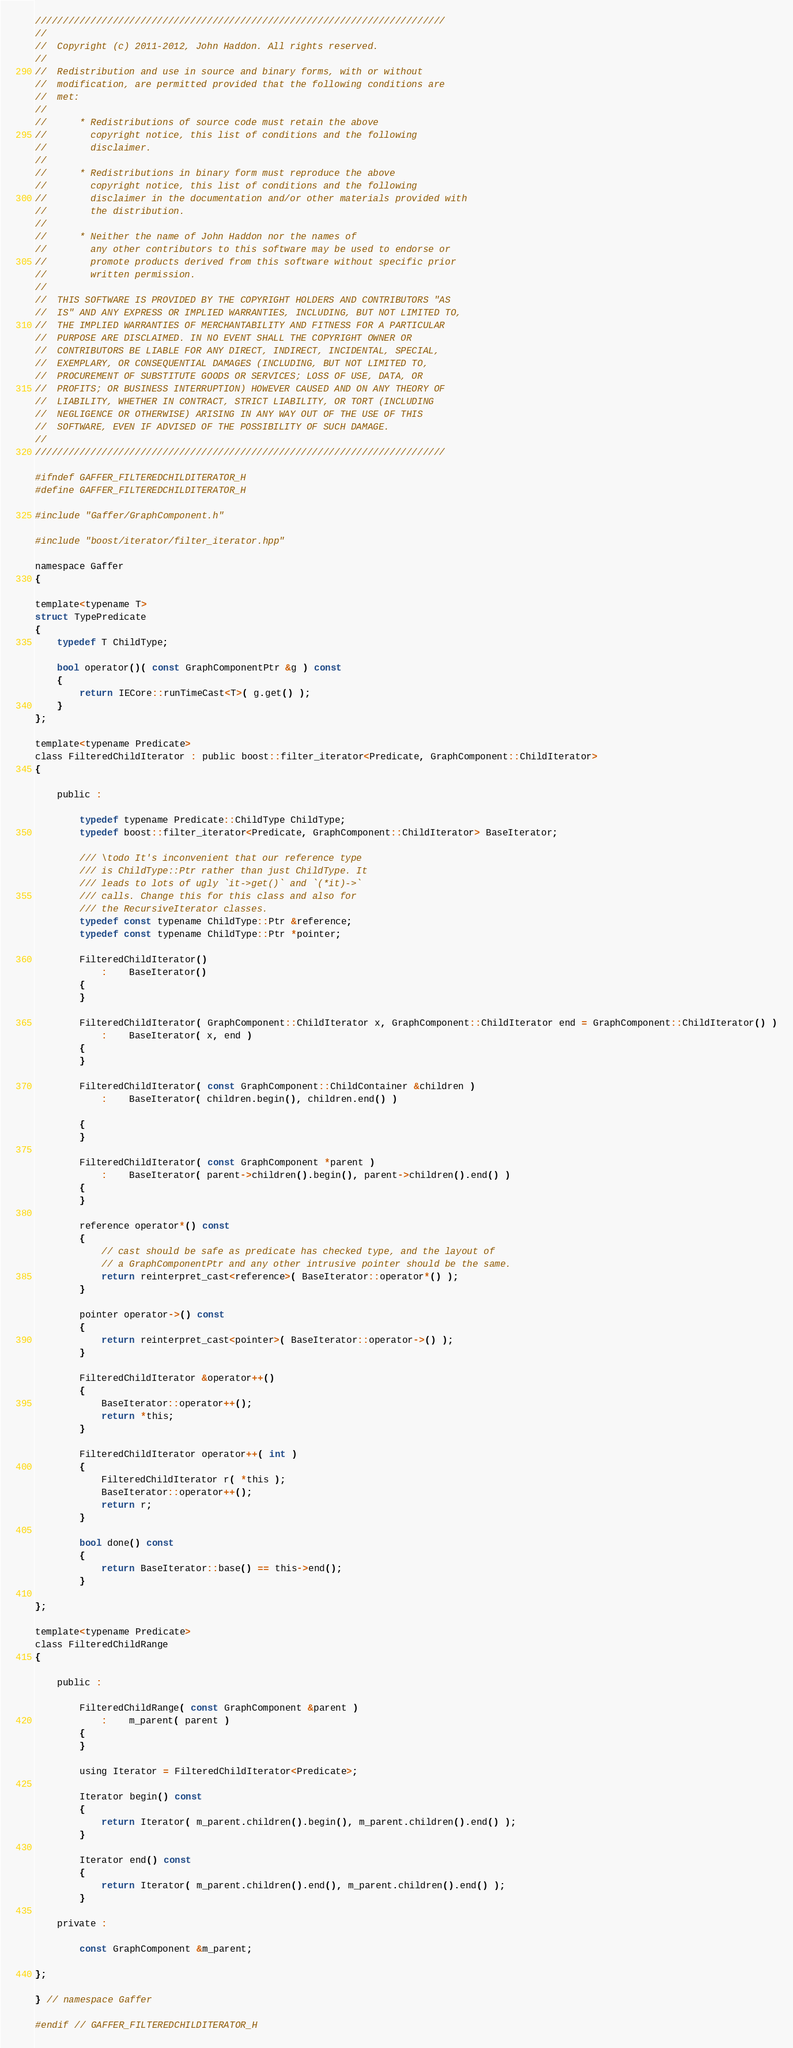<code> <loc_0><loc_0><loc_500><loc_500><_C_>//////////////////////////////////////////////////////////////////////////
//
//  Copyright (c) 2011-2012, John Haddon. All rights reserved.
//
//  Redistribution and use in source and binary forms, with or without
//  modification, are permitted provided that the following conditions are
//  met:
//
//      * Redistributions of source code must retain the above
//        copyright notice, this list of conditions and the following
//        disclaimer.
//
//      * Redistributions in binary form must reproduce the above
//        copyright notice, this list of conditions and the following
//        disclaimer in the documentation and/or other materials provided with
//        the distribution.
//
//      * Neither the name of John Haddon nor the names of
//        any other contributors to this software may be used to endorse or
//        promote products derived from this software without specific prior
//        written permission.
//
//  THIS SOFTWARE IS PROVIDED BY THE COPYRIGHT HOLDERS AND CONTRIBUTORS "AS
//  IS" AND ANY EXPRESS OR IMPLIED WARRANTIES, INCLUDING, BUT NOT LIMITED TO,
//  THE IMPLIED WARRANTIES OF MERCHANTABILITY AND FITNESS FOR A PARTICULAR
//  PURPOSE ARE DISCLAIMED. IN NO EVENT SHALL THE COPYRIGHT OWNER OR
//  CONTRIBUTORS BE LIABLE FOR ANY DIRECT, INDIRECT, INCIDENTAL, SPECIAL,
//  EXEMPLARY, OR CONSEQUENTIAL DAMAGES (INCLUDING, BUT NOT LIMITED TO,
//  PROCUREMENT OF SUBSTITUTE GOODS OR SERVICES; LOSS OF USE, DATA, OR
//  PROFITS; OR BUSINESS INTERRUPTION) HOWEVER CAUSED AND ON ANY THEORY OF
//  LIABILITY, WHETHER IN CONTRACT, STRICT LIABILITY, OR TORT (INCLUDING
//  NEGLIGENCE OR OTHERWISE) ARISING IN ANY WAY OUT OF THE USE OF THIS
//  SOFTWARE, EVEN IF ADVISED OF THE POSSIBILITY OF SUCH DAMAGE.
//
//////////////////////////////////////////////////////////////////////////

#ifndef GAFFER_FILTEREDCHILDITERATOR_H
#define GAFFER_FILTEREDCHILDITERATOR_H

#include "Gaffer/GraphComponent.h"

#include "boost/iterator/filter_iterator.hpp"

namespace Gaffer
{

template<typename T>
struct TypePredicate
{
	typedef T ChildType;

	bool operator()( const GraphComponentPtr &g ) const
	{
		return IECore::runTimeCast<T>( g.get() );
	}
};

template<typename Predicate>
class FilteredChildIterator : public boost::filter_iterator<Predicate, GraphComponent::ChildIterator>
{

	public :

		typedef typename Predicate::ChildType ChildType;
		typedef boost::filter_iterator<Predicate, GraphComponent::ChildIterator> BaseIterator;

		/// \todo It's inconvenient that our reference type
		/// is ChildType::Ptr rather than just ChildType. It
		/// leads to lots of ugly `it->get()` and `(*it)->`
		/// calls. Change this for this class and also for
		/// the RecursiveIterator classes.
		typedef const typename ChildType::Ptr &reference;
		typedef const typename ChildType::Ptr *pointer;

		FilteredChildIterator()
			:	BaseIterator()
		{
		}

		FilteredChildIterator( GraphComponent::ChildIterator x, GraphComponent::ChildIterator end = GraphComponent::ChildIterator() )
			:	BaseIterator( x, end )
		{
		}

		FilteredChildIterator( const GraphComponent::ChildContainer &children )
			:	BaseIterator( children.begin(), children.end() )

		{
		}

		FilteredChildIterator( const GraphComponent *parent )
			:	BaseIterator( parent->children().begin(), parent->children().end() )
		{
		}

		reference operator*() const
		{
			// cast should be safe as predicate has checked type, and the layout of
			// a GraphComponentPtr and any other intrusive pointer should be the same.
			return reinterpret_cast<reference>( BaseIterator::operator*() );
		}

		pointer operator->() const
		{
			return reinterpret_cast<pointer>( BaseIterator::operator->() );
		}

    	FilteredChildIterator &operator++()
		{
			BaseIterator::operator++();
			return *this;
		}

		FilteredChildIterator operator++( int )
		{
			FilteredChildIterator r( *this );
			BaseIterator::operator++();
			return r;
		}

		bool done() const
		{
			return BaseIterator::base() == this->end();
		}

};

template<typename Predicate>
class FilteredChildRange
{

	public :

		FilteredChildRange( const GraphComponent &parent )
			:	m_parent( parent )
		{
		}

		using Iterator = FilteredChildIterator<Predicate>;

		Iterator begin() const
		{
			return Iterator( m_parent.children().begin(), m_parent.children().end() );
		}

		Iterator end() const
		{
			return Iterator( m_parent.children().end(), m_parent.children().end() );
		}

	private :

		const GraphComponent &m_parent;

};

} // namespace Gaffer

#endif // GAFFER_FILTEREDCHILDITERATOR_H
</code> 